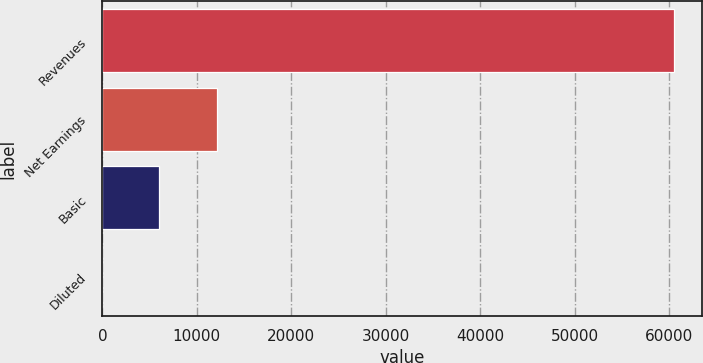<chart> <loc_0><loc_0><loc_500><loc_500><bar_chart><fcel>Revenues<fcel>Net Earnings<fcel>Basic<fcel>Diluted<nl><fcel>60486<fcel>12099.1<fcel>6050.7<fcel>2.33<nl></chart> 